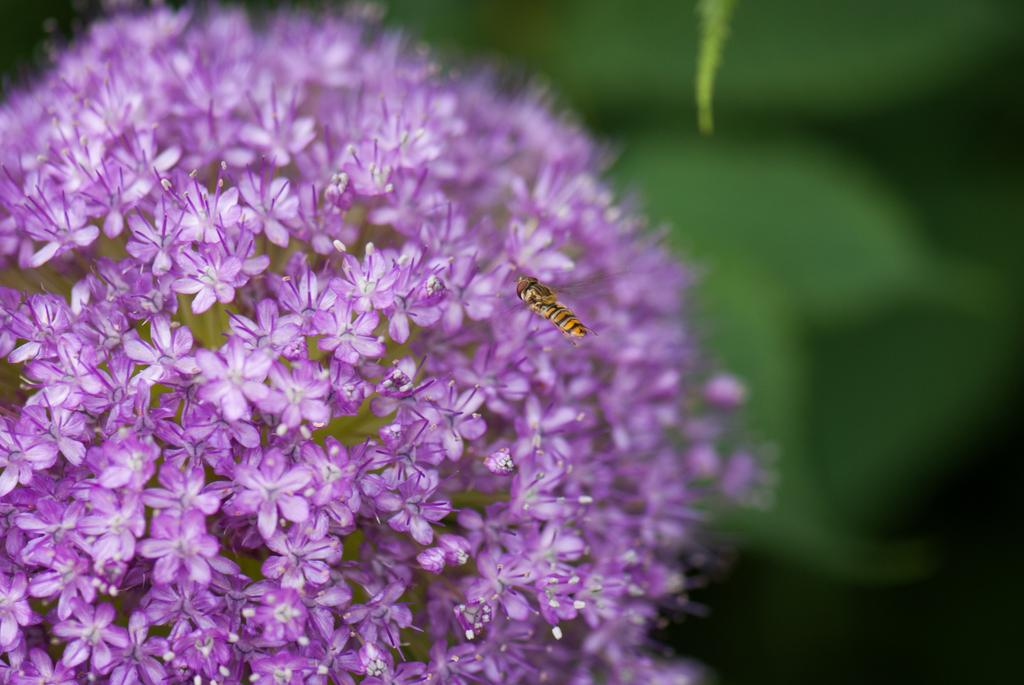What is on the flower in the image? There is an insect on a flower in the image. What can be seen in the background of the image? There are leaves in the background of the image. What other elements are present in the image besides the insect and leaves? There are flowers visible in the image. What type of test is being conducted on the insect in the image? There is no indication in the image that a test is being conducted on the insect. 